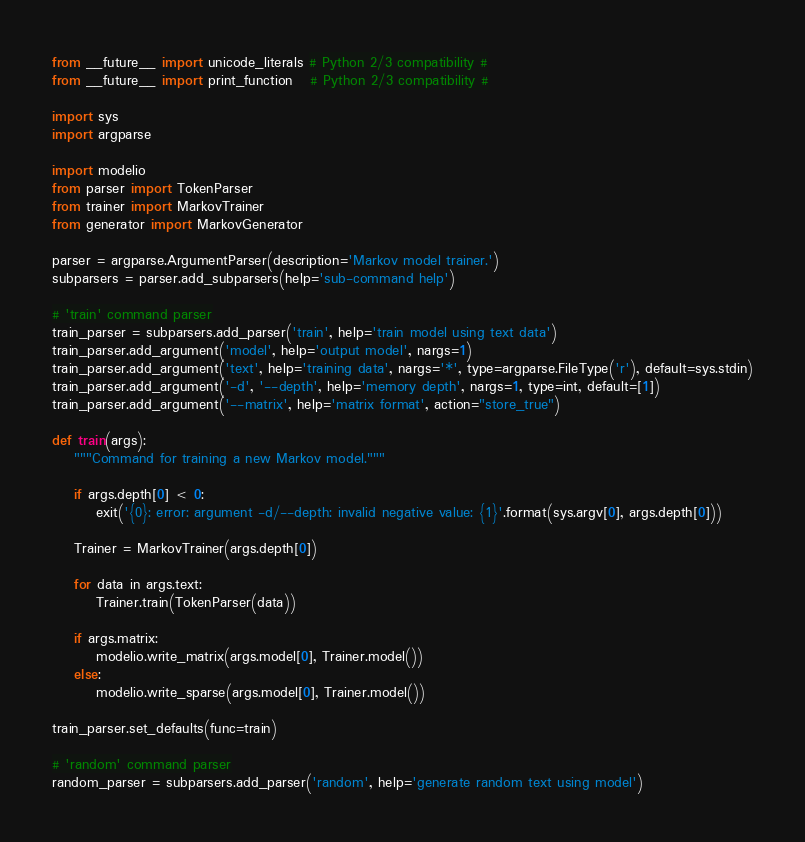Convert code to text. <code><loc_0><loc_0><loc_500><loc_500><_Python_>from __future__ import unicode_literals # Python 2/3 compatibility #
from __future__ import print_function   # Python 2/3 compatibility #

import sys
import argparse

import modelio
from parser import TokenParser
from trainer import MarkovTrainer
from generator import MarkovGenerator

parser = argparse.ArgumentParser(description='Markov model trainer.')
subparsers = parser.add_subparsers(help='sub-command help')

# 'train' command parser
train_parser = subparsers.add_parser('train', help='train model using text data')
train_parser.add_argument('model', help='output model', nargs=1)
train_parser.add_argument('text', help='training data', nargs='*', type=argparse.FileType('r'), default=sys.stdin)
train_parser.add_argument('-d', '--depth', help='memory depth', nargs=1, type=int, default=[1])
train_parser.add_argument('--matrix', help='matrix format', action="store_true")

def train(args):
    """Command for training a new Markov model."""
    
    if args.depth[0] < 0:
        exit('{0}: error: argument -d/--depth: invalid negative value: {1}'.format(sys.argv[0], args.depth[0]))
    
    Trainer = MarkovTrainer(args.depth[0])
    
    for data in args.text:
        Trainer.train(TokenParser(data))
    
    if args.matrix:
        modelio.write_matrix(args.model[0], Trainer.model())
    else:
        modelio.write_sparse(args.model[0], Trainer.model())

train_parser.set_defaults(func=train)

# 'random' command parser
random_parser = subparsers.add_parser('random', help='generate random text using model')</code> 